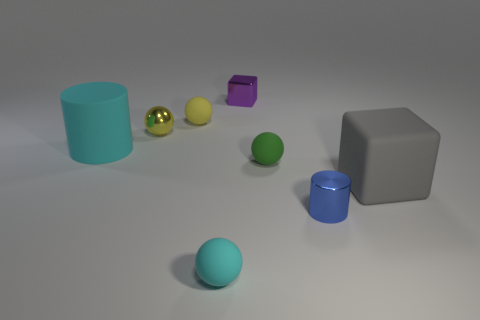Subtract all yellow balls. How many were subtracted if there are1yellow balls left? 1 Subtract 0 purple spheres. How many objects are left? 8 Subtract all blocks. How many objects are left? 6 Subtract 2 spheres. How many spheres are left? 2 Subtract all cyan blocks. Subtract all purple cylinders. How many blocks are left? 2 Subtract all brown spheres. How many yellow cylinders are left? 0 Subtract all cubes. Subtract all cyan rubber things. How many objects are left? 4 Add 7 tiny yellow matte things. How many tiny yellow matte things are left? 8 Add 7 big matte cylinders. How many big matte cylinders exist? 8 Add 1 yellow matte objects. How many objects exist? 9 